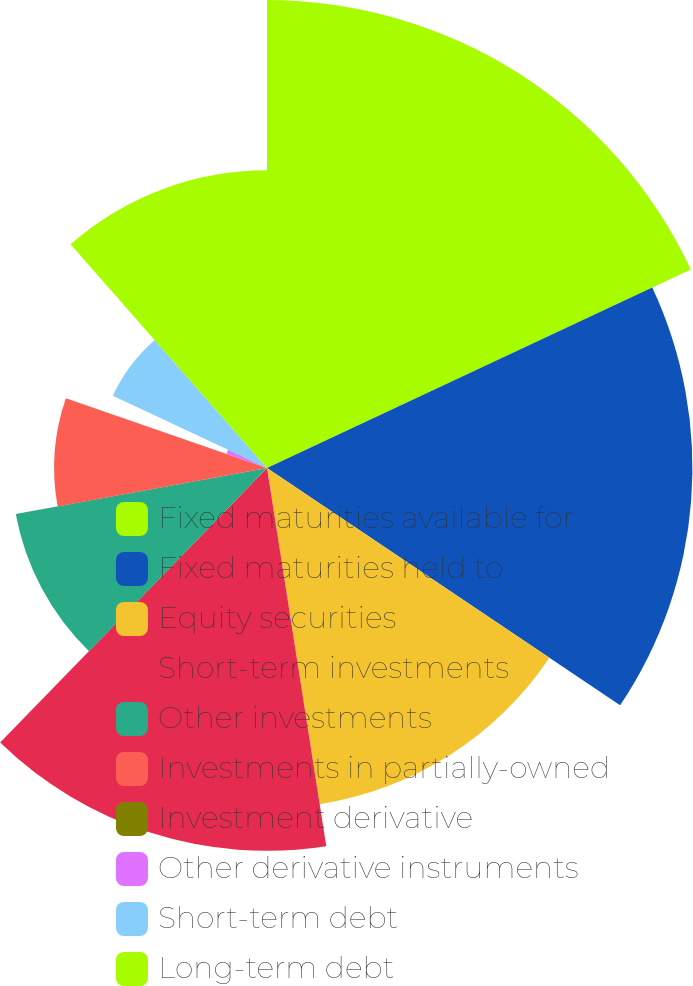Convert chart to OTSL. <chart><loc_0><loc_0><loc_500><loc_500><pie_chart><fcel>Fixed maturities available for<fcel>Fixed maturities held to<fcel>Equity securities<fcel>Short-term investments<fcel>Other investments<fcel>Investments in partially-owned<fcel>Investment derivative<fcel>Other derivative instruments<fcel>Short-term debt<fcel>Long-term debt<nl><fcel>18.03%<fcel>16.39%<fcel>13.11%<fcel>14.75%<fcel>9.84%<fcel>8.2%<fcel>0.01%<fcel>1.65%<fcel>6.56%<fcel>11.47%<nl></chart> 